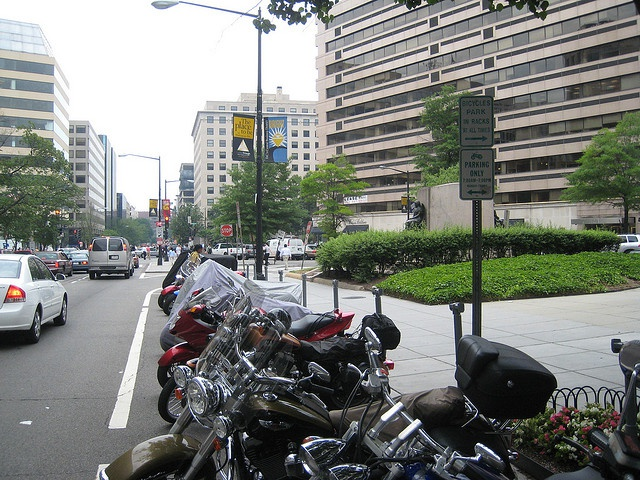Describe the objects in this image and their specific colors. I can see motorcycle in white, black, gray, and darkgray tones, motorcycle in white, black, gray, and navy tones, potted plant in white, black, gray, darkgreen, and darkgray tones, motorcycle in white, black, maroon, gray, and darkgray tones, and car in white, lightgray, darkgray, black, and gray tones in this image. 